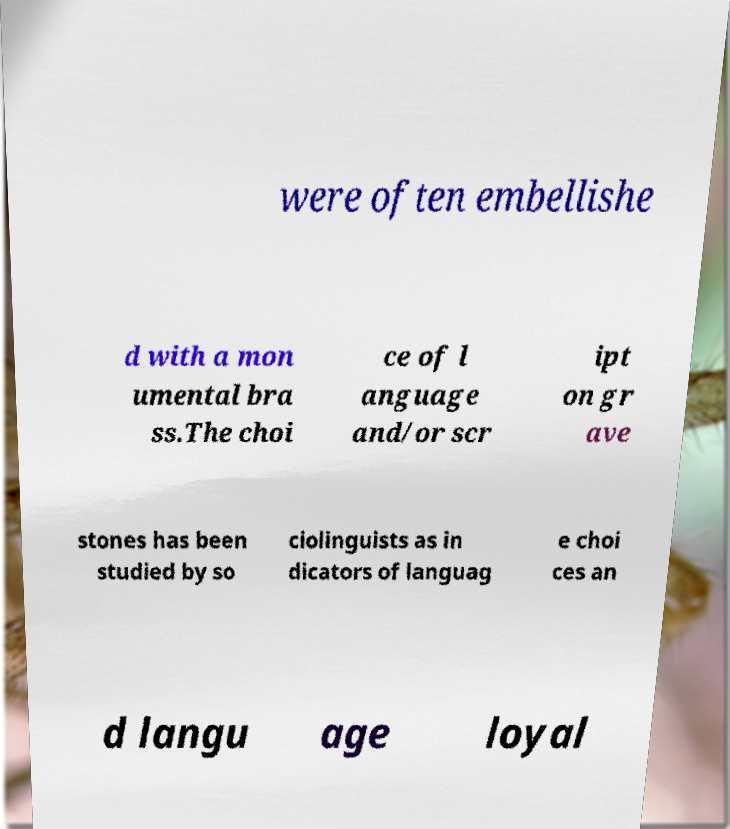Please read and relay the text visible in this image. What does it say? were often embellishe d with a mon umental bra ss.The choi ce of l anguage and/or scr ipt on gr ave stones has been studied by so ciolinguists as in dicators of languag e choi ces an d langu age loyal 